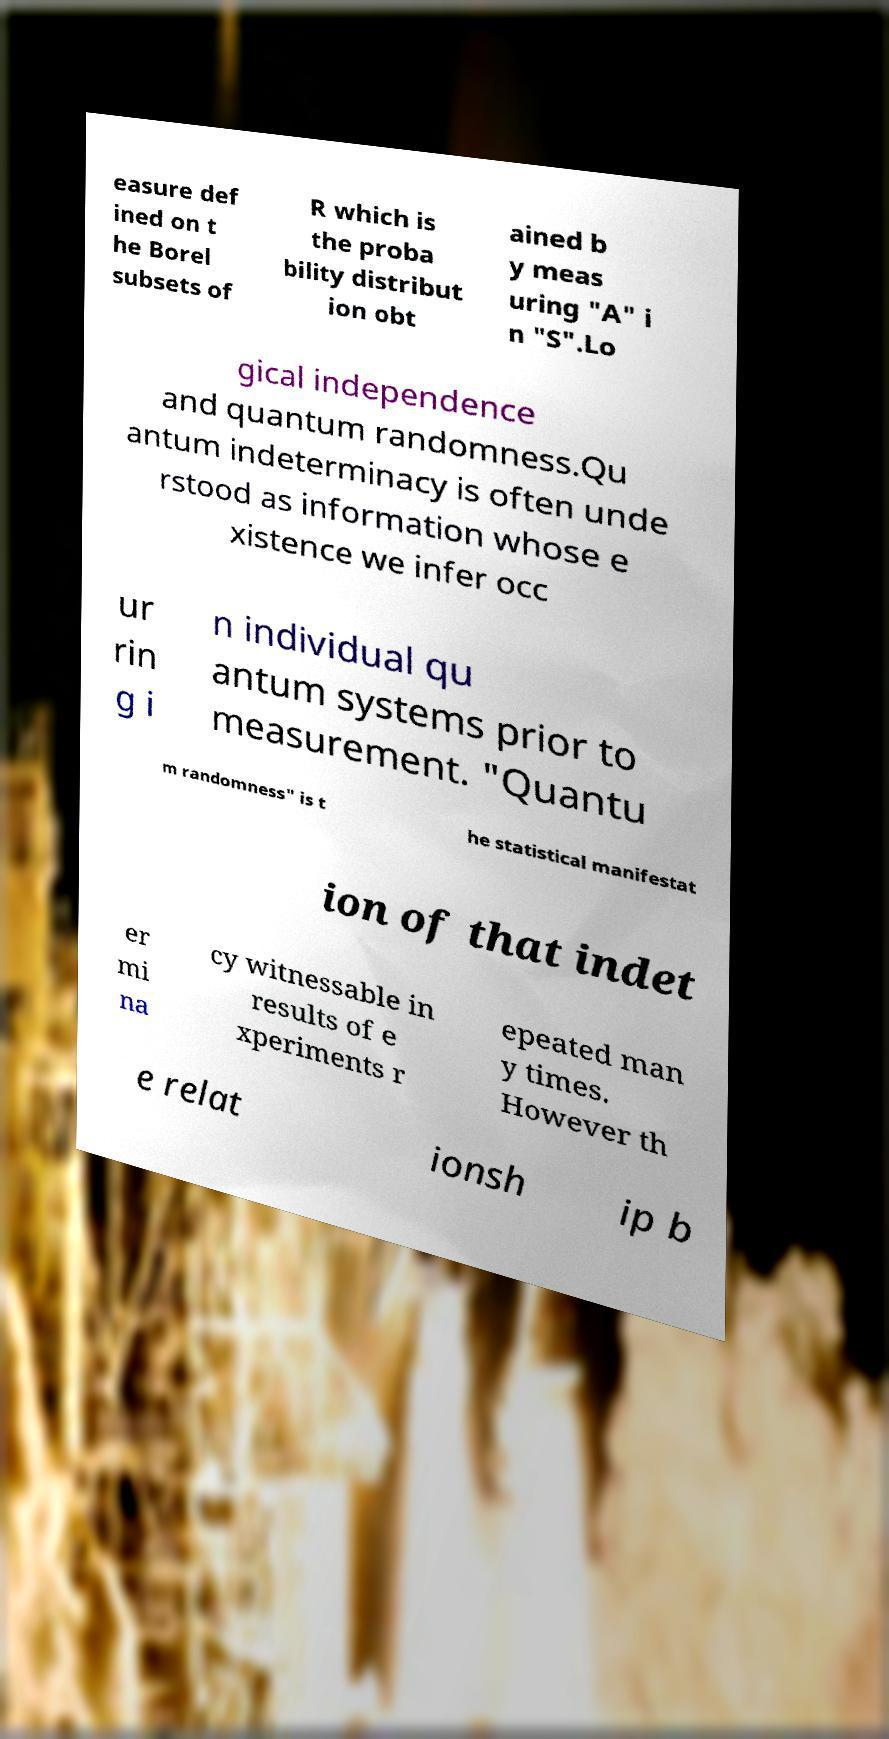Please identify and transcribe the text found in this image. easure def ined on t he Borel subsets of R which is the proba bility distribut ion obt ained b y meas uring "A" i n "S".Lo gical independence and quantum randomness.Qu antum indeterminacy is often unde rstood as information whose e xistence we infer occ ur rin g i n individual qu antum systems prior to measurement. "Quantu m randomness" is t he statistical manifestat ion of that indet er mi na cy witnessable in results of e xperiments r epeated man y times. However th e relat ionsh ip b 